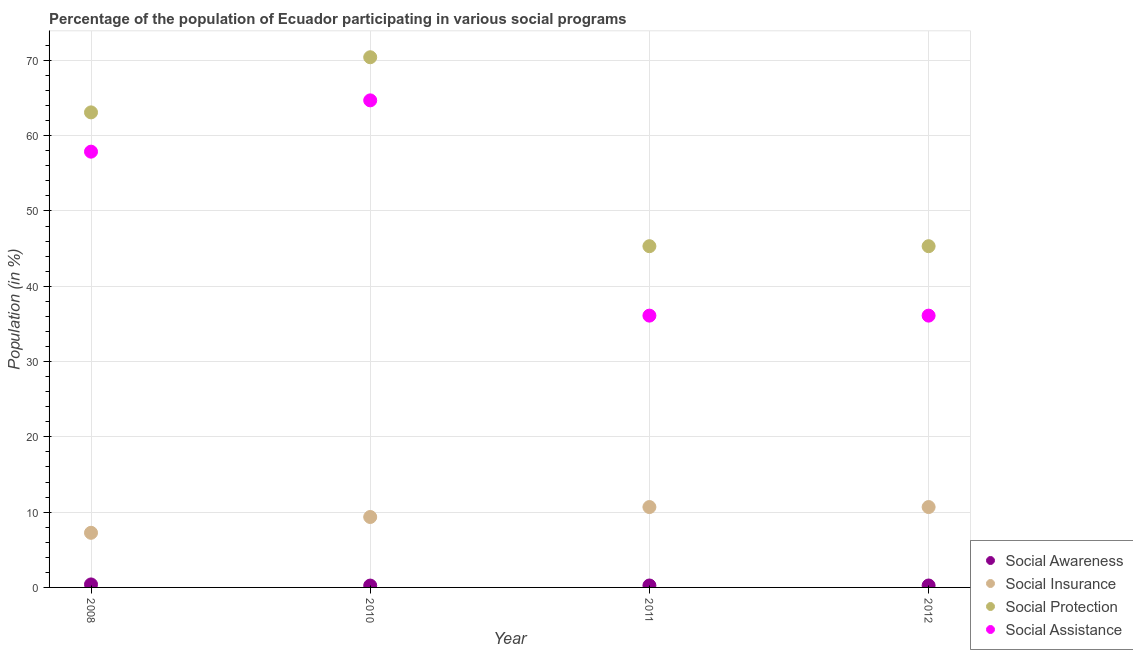Is the number of dotlines equal to the number of legend labels?
Offer a terse response. Yes. What is the participation of population in social insurance programs in 2008?
Your response must be concise. 7.26. Across all years, what is the maximum participation of population in social assistance programs?
Keep it short and to the point. 64.69. Across all years, what is the minimum participation of population in social protection programs?
Provide a succinct answer. 45.32. What is the total participation of population in social protection programs in the graph?
Keep it short and to the point. 224.15. What is the difference between the participation of population in social insurance programs in 2010 and that in 2011?
Keep it short and to the point. -1.32. What is the difference between the participation of population in social protection programs in 2012 and the participation of population in social insurance programs in 2008?
Offer a very short reply. 38.07. What is the average participation of population in social awareness programs per year?
Your response must be concise. 0.29. In the year 2010, what is the difference between the participation of population in social insurance programs and participation of population in social protection programs?
Keep it short and to the point. -61.06. In how many years, is the participation of population in social assistance programs greater than 20 %?
Keep it short and to the point. 4. What is the ratio of the participation of population in social protection programs in 2008 to that in 2011?
Provide a short and direct response. 1.39. Is the participation of population in social awareness programs in 2008 less than that in 2011?
Provide a short and direct response. No. Is the difference between the participation of population in social awareness programs in 2008 and 2010 greater than the difference between the participation of population in social assistance programs in 2008 and 2010?
Give a very brief answer. Yes. What is the difference between the highest and the second highest participation of population in social protection programs?
Provide a succinct answer. 7.32. What is the difference between the highest and the lowest participation of population in social awareness programs?
Provide a succinct answer. 0.15. In how many years, is the participation of population in social assistance programs greater than the average participation of population in social assistance programs taken over all years?
Make the answer very short. 2. Is the sum of the participation of population in social protection programs in 2008 and 2011 greater than the maximum participation of population in social insurance programs across all years?
Keep it short and to the point. Yes. Is it the case that in every year, the sum of the participation of population in social assistance programs and participation of population in social awareness programs is greater than the sum of participation of population in social protection programs and participation of population in social insurance programs?
Provide a short and direct response. No. Is the participation of population in social protection programs strictly greater than the participation of population in social insurance programs over the years?
Your response must be concise. Yes. Is the participation of population in social assistance programs strictly less than the participation of population in social insurance programs over the years?
Make the answer very short. No. Does the graph contain any zero values?
Provide a succinct answer. No. Does the graph contain grids?
Offer a terse response. Yes. Where does the legend appear in the graph?
Offer a terse response. Bottom right. How are the legend labels stacked?
Provide a succinct answer. Vertical. What is the title of the graph?
Your answer should be compact. Percentage of the population of Ecuador participating in various social programs . Does "Regional development banks" appear as one of the legend labels in the graph?
Give a very brief answer. No. What is the Population (in %) of Social Awareness in 2008?
Your answer should be compact. 0.4. What is the Population (in %) of Social Insurance in 2008?
Your response must be concise. 7.26. What is the Population (in %) of Social Protection in 2008?
Keep it short and to the point. 63.09. What is the Population (in %) in Social Assistance in 2008?
Keep it short and to the point. 57.88. What is the Population (in %) of Social Awareness in 2010?
Offer a terse response. 0.25. What is the Population (in %) in Social Insurance in 2010?
Keep it short and to the point. 9.35. What is the Population (in %) in Social Protection in 2010?
Your answer should be very brief. 70.42. What is the Population (in %) of Social Assistance in 2010?
Ensure brevity in your answer.  64.69. What is the Population (in %) of Social Awareness in 2011?
Give a very brief answer. 0.26. What is the Population (in %) of Social Insurance in 2011?
Provide a short and direct response. 10.67. What is the Population (in %) of Social Protection in 2011?
Provide a short and direct response. 45.32. What is the Population (in %) in Social Assistance in 2011?
Provide a short and direct response. 36.1. What is the Population (in %) in Social Awareness in 2012?
Your answer should be very brief. 0.26. What is the Population (in %) in Social Insurance in 2012?
Offer a terse response. 10.67. What is the Population (in %) in Social Protection in 2012?
Your response must be concise. 45.32. What is the Population (in %) in Social Assistance in 2012?
Your response must be concise. 36.1. Across all years, what is the maximum Population (in %) in Social Awareness?
Offer a very short reply. 0.4. Across all years, what is the maximum Population (in %) in Social Insurance?
Ensure brevity in your answer.  10.67. Across all years, what is the maximum Population (in %) in Social Protection?
Your answer should be compact. 70.42. Across all years, what is the maximum Population (in %) in Social Assistance?
Your response must be concise. 64.69. Across all years, what is the minimum Population (in %) of Social Awareness?
Give a very brief answer. 0.25. Across all years, what is the minimum Population (in %) of Social Insurance?
Your answer should be very brief. 7.26. Across all years, what is the minimum Population (in %) in Social Protection?
Keep it short and to the point. 45.32. Across all years, what is the minimum Population (in %) in Social Assistance?
Make the answer very short. 36.1. What is the total Population (in %) in Social Awareness in the graph?
Your answer should be compact. 1.16. What is the total Population (in %) in Social Insurance in the graph?
Ensure brevity in your answer.  37.96. What is the total Population (in %) of Social Protection in the graph?
Keep it short and to the point. 224.15. What is the total Population (in %) in Social Assistance in the graph?
Give a very brief answer. 194.76. What is the difference between the Population (in %) of Social Awareness in 2008 and that in 2010?
Your answer should be very brief. 0.15. What is the difference between the Population (in %) of Social Insurance in 2008 and that in 2010?
Your response must be concise. -2.1. What is the difference between the Population (in %) in Social Protection in 2008 and that in 2010?
Keep it short and to the point. -7.32. What is the difference between the Population (in %) in Social Assistance in 2008 and that in 2010?
Keep it short and to the point. -6.81. What is the difference between the Population (in %) of Social Awareness in 2008 and that in 2011?
Your response must be concise. 0.14. What is the difference between the Population (in %) of Social Insurance in 2008 and that in 2011?
Give a very brief answer. -3.42. What is the difference between the Population (in %) in Social Protection in 2008 and that in 2011?
Give a very brief answer. 17.77. What is the difference between the Population (in %) of Social Assistance in 2008 and that in 2011?
Your answer should be very brief. 21.78. What is the difference between the Population (in %) in Social Awareness in 2008 and that in 2012?
Offer a very short reply. 0.14. What is the difference between the Population (in %) of Social Insurance in 2008 and that in 2012?
Provide a short and direct response. -3.42. What is the difference between the Population (in %) in Social Protection in 2008 and that in 2012?
Offer a terse response. 17.77. What is the difference between the Population (in %) in Social Assistance in 2008 and that in 2012?
Your response must be concise. 21.78. What is the difference between the Population (in %) in Social Awareness in 2010 and that in 2011?
Your answer should be compact. -0.01. What is the difference between the Population (in %) of Social Insurance in 2010 and that in 2011?
Give a very brief answer. -1.32. What is the difference between the Population (in %) of Social Protection in 2010 and that in 2011?
Your answer should be compact. 25.1. What is the difference between the Population (in %) in Social Assistance in 2010 and that in 2011?
Make the answer very short. 28.59. What is the difference between the Population (in %) in Social Awareness in 2010 and that in 2012?
Provide a short and direct response. -0.01. What is the difference between the Population (in %) in Social Insurance in 2010 and that in 2012?
Make the answer very short. -1.32. What is the difference between the Population (in %) of Social Protection in 2010 and that in 2012?
Your response must be concise. 25.1. What is the difference between the Population (in %) in Social Assistance in 2010 and that in 2012?
Make the answer very short. 28.59. What is the difference between the Population (in %) of Social Awareness in 2011 and that in 2012?
Provide a succinct answer. 0. What is the difference between the Population (in %) of Social Assistance in 2011 and that in 2012?
Your answer should be very brief. 0. What is the difference between the Population (in %) of Social Awareness in 2008 and the Population (in %) of Social Insurance in 2010?
Ensure brevity in your answer.  -8.96. What is the difference between the Population (in %) of Social Awareness in 2008 and the Population (in %) of Social Protection in 2010?
Offer a terse response. -70.02. What is the difference between the Population (in %) of Social Awareness in 2008 and the Population (in %) of Social Assistance in 2010?
Keep it short and to the point. -64.29. What is the difference between the Population (in %) of Social Insurance in 2008 and the Population (in %) of Social Protection in 2010?
Provide a short and direct response. -63.16. What is the difference between the Population (in %) of Social Insurance in 2008 and the Population (in %) of Social Assistance in 2010?
Ensure brevity in your answer.  -57.43. What is the difference between the Population (in %) in Social Protection in 2008 and the Population (in %) in Social Assistance in 2010?
Provide a succinct answer. -1.6. What is the difference between the Population (in %) of Social Awareness in 2008 and the Population (in %) of Social Insurance in 2011?
Make the answer very short. -10.28. What is the difference between the Population (in %) in Social Awareness in 2008 and the Population (in %) in Social Protection in 2011?
Your response must be concise. -44.92. What is the difference between the Population (in %) of Social Awareness in 2008 and the Population (in %) of Social Assistance in 2011?
Provide a succinct answer. -35.7. What is the difference between the Population (in %) in Social Insurance in 2008 and the Population (in %) in Social Protection in 2011?
Make the answer very short. -38.07. What is the difference between the Population (in %) in Social Insurance in 2008 and the Population (in %) in Social Assistance in 2011?
Provide a succinct answer. -28.84. What is the difference between the Population (in %) of Social Protection in 2008 and the Population (in %) of Social Assistance in 2011?
Provide a succinct answer. 26.99. What is the difference between the Population (in %) in Social Awareness in 2008 and the Population (in %) in Social Insurance in 2012?
Make the answer very short. -10.28. What is the difference between the Population (in %) in Social Awareness in 2008 and the Population (in %) in Social Protection in 2012?
Keep it short and to the point. -44.92. What is the difference between the Population (in %) in Social Awareness in 2008 and the Population (in %) in Social Assistance in 2012?
Your answer should be very brief. -35.7. What is the difference between the Population (in %) in Social Insurance in 2008 and the Population (in %) in Social Protection in 2012?
Offer a very short reply. -38.07. What is the difference between the Population (in %) of Social Insurance in 2008 and the Population (in %) of Social Assistance in 2012?
Your response must be concise. -28.84. What is the difference between the Population (in %) in Social Protection in 2008 and the Population (in %) in Social Assistance in 2012?
Your response must be concise. 26.99. What is the difference between the Population (in %) in Social Awareness in 2010 and the Population (in %) in Social Insurance in 2011?
Provide a short and direct response. -10.43. What is the difference between the Population (in %) of Social Awareness in 2010 and the Population (in %) of Social Protection in 2011?
Give a very brief answer. -45.07. What is the difference between the Population (in %) of Social Awareness in 2010 and the Population (in %) of Social Assistance in 2011?
Your answer should be very brief. -35.85. What is the difference between the Population (in %) in Social Insurance in 2010 and the Population (in %) in Social Protection in 2011?
Provide a succinct answer. -35.97. What is the difference between the Population (in %) of Social Insurance in 2010 and the Population (in %) of Social Assistance in 2011?
Your response must be concise. -26.74. What is the difference between the Population (in %) in Social Protection in 2010 and the Population (in %) in Social Assistance in 2011?
Offer a very short reply. 34.32. What is the difference between the Population (in %) in Social Awareness in 2010 and the Population (in %) in Social Insurance in 2012?
Provide a succinct answer. -10.43. What is the difference between the Population (in %) of Social Awareness in 2010 and the Population (in %) of Social Protection in 2012?
Provide a succinct answer. -45.07. What is the difference between the Population (in %) of Social Awareness in 2010 and the Population (in %) of Social Assistance in 2012?
Make the answer very short. -35.85. What is the difference between the Population (in %) in Social Insurance in 2010 and the Population (in %) in Social Protection in 2012?
Give a very brief answer. -35.97. What is the difference between the Population (in %) of Social Insurance in 2010 and the Population (in %) of Social Assistance in 2012?
Provide a short and direct response. -26.74. What is the difference between the Population (in %) of Social Protection in 2010 and the Population (in %) of Social Assistance in 2012?
Offer a terse response. 34.32. What is the difference between the Population (in %) in Social Awareness in 2011 and the Population (in %) in Social Insurance in 2012?
Your answer should be very brief. -10.42. What is the difference between the Population (in %) of Social Awareness in 2011 and the Population (in %) of Social Protection in 2012?
Keep it short and to the point. -45.06. What is the difference between the Population (in %) in Social Awareness in 2011 and the Population (in %) in Social Assistance in 2012?
Provide a short and direct response. -35.84. What is the difference between the Population (in %) in Social Insurance in 2011 and the Population (in %) in Social Protection in 2012?
Keep it short and to the point. -34.65. What is the difference between the Population (in %) of Social Insurance in 2011 and the Population (in %) of Social Assistance in 2012?
Offer a terse response. -25.42. What is the difference between the Population (in %) of Social Protection in 2011 and the Population (in %) of Social Assistance in 2012?
Give a very brief answer. 9.22. What is the average Population (in %) of Social Awareness per year?
Keep it short and to the point. 0.29. What is the average Population (in %) of Social Insurance per year?
Provide a short and direct response. 9.49. What is the average Population (in %) in Social Protection per year?
Offer a very short reply. 56.04. What is the average Population (in %) in Social Assistance per year?
Your answer should be compact. 48.69. In the year 2008, what is the difference between the Population (in %) in Social Awareness and Population (in %) in Social Insurance?
Provide a succinct answer. -6.86. In the year 2008, what is the difference between the Population (in %) in Social Awareness and Population (in %) in Social Protection?
Your answer should be compact. -62.7. In the year 2008, what is the difference between the Population (in %) of Social Awareness and Population (in %) of Social Assistance?
Your answer should be compact. -57.48. In the year 2008, what is the difference between the Population (in %) of Social Insurance and Population (in %) of Social Protection?
Ensure brevity in your answer.  -55.84. In the year 2008, what is the difference between the Population (in %) of Social Insurance and Population (in %) of Social Assistance?
Offer a very short reply. -50.62. In the year 2008, what is the difference between the Population (in %) of Social Protection and Population (in %) of Social Assistance?
Provide a short and direct response. 5.22. In the year 2010, what is the difference between the Population (in %) of Social Awareness and Population (in %) of Social Insurance?
Make the answer very short. -9.11. In the year 2010, what is the difference between the Population (in %) of Social Awareness and Population (in %) of Social Protection?
Offer a very short reply. -70.17. In the year 2010, what is the difference between the Population (in %) in Social Awareness and Population (in %) in Social Assistance?
Offer a terse response. -64.44. In the year 2010, what is the difference between the Population (in %) in Social Insurance and Population (in %) in Social Protection?
Offer a very short reply. -61.06. In the year 2010, what is the difference between the Population (in %) of Social Insurance and Population (in %) of Social Assistance?
Your answer should be very brief. -55.33. In the year 2010, what is the difference between the Population (in %) of Social Protection and Population (in %) of Social Assistance?
Keep it short and to the point. 5.73. In the year 2011, what is the difference between the Population (in %) in Social Awareness and Population (in %) in Social Insurance?
Your answer should be very brief. -10.42. In the year 2011, what is the difference between the Population (in %) of Social Awareness and Population (in %) of Social Protection?
Make the answer very short. -45.06. In the year 2011, what is the difference between the Population (in %) of Social Awareness and Population (in %) of Social Assistance?
Make the answer very short. -35.84. In the year 2011, what is the difference between the Population (in %) of Social Insurance and Population (in %) of Social Protection?
Give a very brief answer. -34.65. In the year 2011, what is the difference between the Population (in %) of Social Insurance and Population (in %) of Social Assistance?
Provide a short and direct response. -25.42. In the year 2011, what is the difference between the Population (in %) of Social Protection and Population (in %) of Social Assistance?
Ensure brevity in your answer.  9.22. In the year 2012, what is the difference between the Population (in %) of Social Awareness and Population (in %) of Social Insurance?
Your answer should be compact. -10.42. In the year 2012, what is the difference between the Population (in %) of Social Awareness and Population (in %) of Social Protection?
Provide a succinct answer. -45.06. In the year 2012, what is the difference between the Population (in %) in Social Awareness and Population (in %) in Social Assistance?
Offer a terse response. -35.84. In the year 2012, what is the difference between the Population (in %) in Social Insurance and Population (in %) in Social Protection?
Your answer should be very brief. -34.65. In the year 2012, what is the difference between the Population (in %) of Social Insurance and Population (in %) of Social Assistance?
Ensure brevity in your answer.  -25.42. In the year 2012, what is the difference between the Population (in %) in Social Protection and Population (in %) in Social Assistance?
Provide a succinct answer. 9.22. What is the ratio of the Population (in %) in Social Awareness in 2008 to that in 2010?
Provide a succinct answer. 1.62. What is the ratio of the Population (in %) of Social Insurance in 2008 to that in 2010?
Give a very brief answer. 0.78. What is the ratio of the Population (in %) in Social Protection in 2008 to that in 2010?
Your answer should be very brief. 0.9. What is the ratio of the Population (in %) of Social Assistance in 2008 to that in 2010?
Keep it short and to the point. 0.89. What is the ratio of the Population (in %) of Social Awareness in 2008 to that in 2011?
Your answer should be compact. 1.55. What is the ratio of the Population (in %) in Social Insurance in 2008 to that in 2011?
Give a very brief answer. 0.68. What is the ratio of the Population (in %) of Social Protection in 2008 to that in 2011?
Your answer should be very brief. 1.39. What is the ratio of the Population (in %) in Social Assistance in 2008 to that in 2011?
Ensure brevity in your answer.  1.6. What is the ratio of the Population (in %) of Social Awareness in 2008 to that in 2012?
Offer a very short reply. 1.55. What is the ratio of the Population (in %) in Social Insurance in 2008 to that in 2012?
Give a very brief answer. 0.68. What is the ratio of the Population (in %) in Social Protection in 2008 to that in 2012?
Offer a very short reply. 1.39. What is the ratio of the Population (in %) in Social Assistance in 2008 to that in 2012?
Keep it short and to the point. 1.6. What is the ratio of the Population (in %) of Social Awareness in 2010 to that in 2011?
Your answer should be compact. 0.96. What is the ratio of the Population (in %) of Social Insurance in 2010 to that in 2011?
Your answer should be compact. 0.88. What is the ratio of the Population (in %) in Social Protection in 2010 to that in 2011?
Your answer should be compact. 1.55. What is the ratio of the Population (in %) of Social Assistance in 2010 to that in 2011?
Provide a succinct answer. 1.79. What is the ratio of the Population (in %) of Social Awareness in 2010 to that in 2012?
Make the answer very short. 0.96. What is the ratio of the Population (in %) in Social Insurance in 2010 to that in 2012?
Provide a short and direct response. 0.88. What is the ratio of the Population (in %) of Social Protection in 2010 to that in 2012?
Make the answer very short. 1.55. What is the ratio of the Population (in %) in Social Assistance in 2010 to that in 2012?
Provide a short and direct response. 1.79. What is the ratio of the Population (in %) in Social Insurance in 2011 to that in 2012?
Your response must be concise. 1. What is the ratio of the Population (in %) in Social Protection in 2011 to that in 2012?
Provide a short and direct response. 1. What is the difference between the highest and the second highest Population (in %) in Social Awareness?
Provide a short and direct response. 0.14. What is the difference between the highest and the second highest Population (in %) of Social Insurance?
Provide a short and direct response. 0. What is the difference between the highest and the second highest Population (in %) in Social Protection?
Provide a short and direct response. 7.32. What is the difference between the highest and the second highest Population (in %) in Social Assistance?
Ensure brevity in your answer.  6.81. What is the difference between the highest and the lowest Population (in %) of Social Awareness?
Offer a very short reply. 0.15. What is the difference between the highest and the lowest Population (in %) of Social Insurance?
Give a very brief answer. 3.42. What is the difference between the highest and the lowest Population (in %) in Social Protection?
Offer a terse response. 25.1. What is the difference between the highest and the lowest Population (in %) in Social Assistance?
Provide a short and direct response. 28.59. 